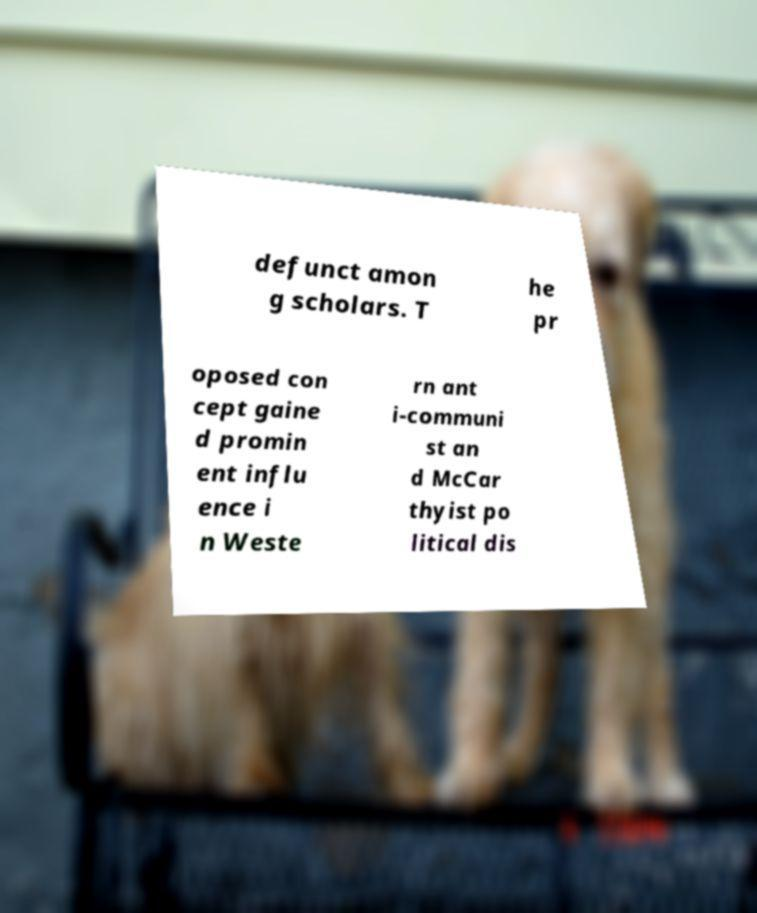What messages or text are displayed in this image? I need them in a readable, typed format. defunct amon g scholars. T he pr oposed con cept gaine d promin ent influ ence i n Weste rn ant i-communi st an d McCar thyist po litical dis 